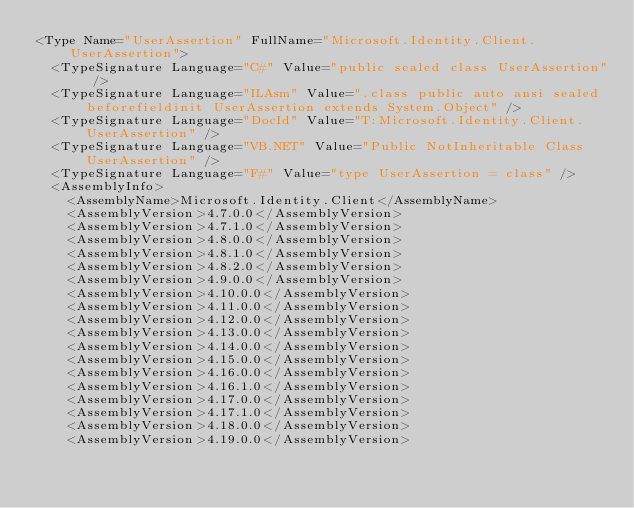<code> <loc_0><loc_0><loc_500><loc_500><_XML_><Type Name="UserAssertion" FullName="Microsoft.Identity.Client.UserAssertion">
  <TypeSignature Language="C#" Value="public sealed class UserAssertion" />
  <TypeSignature Language="ILAsm" Value=".class public auto ansi sealed beforefieldinit UserAssertion extends System.Object" />
  <TypeSignature Language="DocId" Value="T:Microsoft.Identity.Client.UserAssertion" />
  <TypeSignature Language="VB.NET" Value="Public NotInheritable Class UserAssertion" />
  <TypeSignature Language="F#" Value="type UserAssertion = class" />
  <AssemblyInfo>
    <AssemblyName>Microsoft.Identity.Client</AssemblyName>
    <AssemblyVersion>4.7.0.0</AssemblyVersion>
    <AssemblyVersion>4.7.1.0</AssemblyVersion>
    <AssemblyVersion>4.8.0.0</AssemblyVersion>
    <AssemblyVersion>4.8.1.0</AssemblyVersion>
    <AssemblyVersion>4.8.2.0</AssemblyVersion>
    <AssemblyVersion>4.9.0.0</AssemblyVersion>
    <AssemblyVersion>4.10.0.0</AssemblyVersion>
    <AssemblyVersion>4.11.0.0</AssemblyVersion>
    <AssemblyVersion>4.12.0.0</AssemblyVersion>
    <AssemblyVersion>4.13.0.0</AssemblyVersion>
    <AssemblyVersion>4.14.0.0</AssemblyVersion>
    <AssemblyVersion>4.15.0.0</AssemblyVersion>
    <AssemblyVersion>4.16.0.0</AssemblyVersion>
    <AssemblyVersion>4.16.1.0</AssemblyVersion>
    <AssemblyVersion>4.17.0.0</AssemblyVersion>
    <AssemblyVersion>4.17.1.0</AssemblyVersion>
    <AssemblyVersion>4.18.0.0</AssemblyVersion>
    <AssemblyVersion>4.19.0.0</AssemblyVersion></code> 